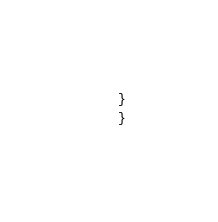Convert code to text. <code><loc_0><loc_0><loc_500><loc_500><_C++_>}
}
</code> 